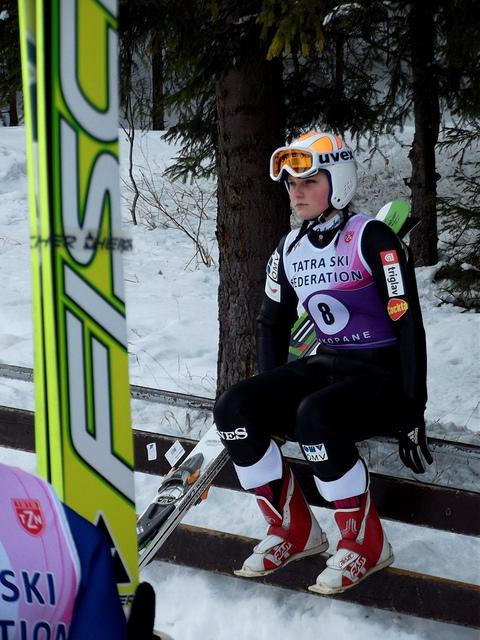What is the child wearing?

Choices:
A) purse
B) goggles
C) crown
D) backpack goggles 